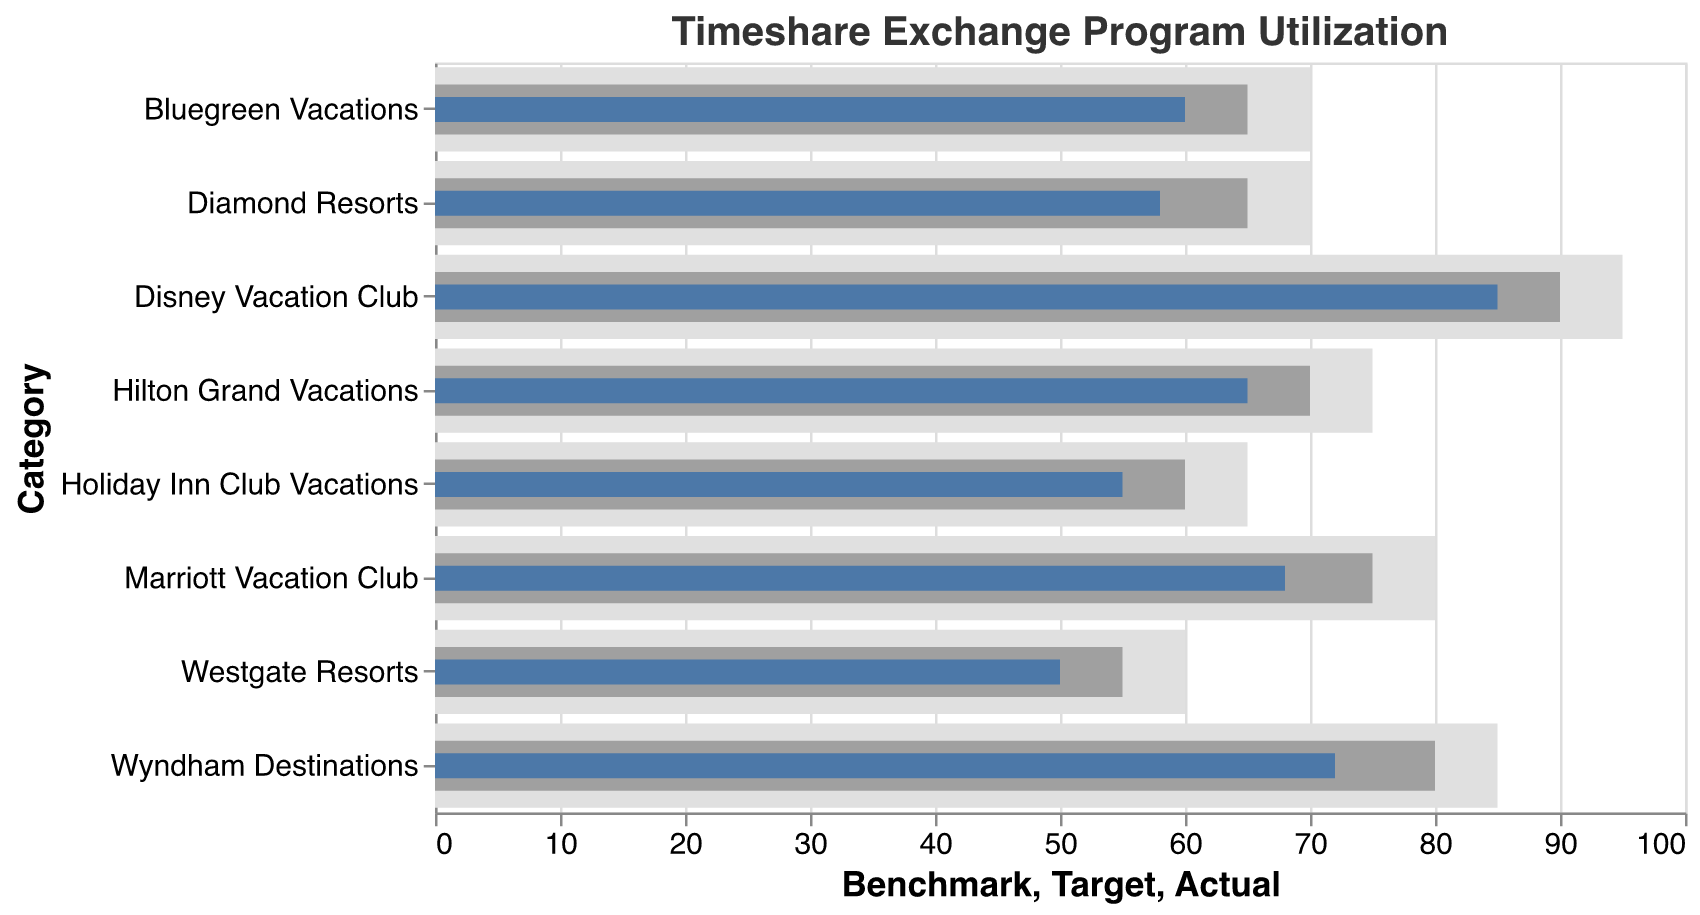What's the title of the chart? The title is typically the text at the top of the visual chart which summarizes its content. Here, it reads "Timeshare Exchange Program Utilization".
Answer: Timeshare Exchange Program Utilization How many categories of timeshare programs are depicted in the chart? Each horizontal bar corresponds to a distinct timeshare program category. Counting each bar, it reveals there are eight categories listed.
Answer: Eight Which timeshare program has the highest actual utilization percentage? To find the highest actual utilization percentage, inspect the blue bars' lengths, as they represent actual utilization. The longest blue bar is for "Disney Vacation Club" with an actual percentage of 85%.
Answer: Disney Vacation Club Which timeshare program falls the most below its utilization target? Calculate the difference between the target and actual for each category. The largest difference occurs for "Holiday Inn Club Vacations", where the target is 60%, and the actual is 55%, resulting in a difference of 5%.
Answer: Holiday Inn Club Vacations Compare the actual utilization of "Marriott Vacation Club" and "Hilton Grand Vacations". Which is higher? Compare the blue bars' lengths for both categories. "Marriott Vacation Club" has an actual utilization of 68%, while "Hilton Grand Vacations" has 65%. Thus, "Marriott Vacation Club" is higher.
Answer: Marriott Vacation Club Which program has its actual usage closest to the benchmark? Examine the difference between the actual utilization and the benchmark for each category. The smallest difference is for "Marriott Vacation Club," where the benchmark is 80% and the actual usage is 68%, a difference of 12%.
Answer: Marriott Vacation Club What's the combined target utilization percentage for "Wyndham Destinations" and "Westgate Resorts"? Sum the target percentages for both categories. Wyndham Destinations' target is 80%, and Westgate Resorts' target is 55%, thus the combined target is 80% + 55% = 135%.
Answer: 135% How does the target utilization for "Bluegreen Vacations" compare to the actual utilization for "Diamond Resorts"? "Bluegreen Vacations" has a target utilization of 65%, while "Diamond Resorts" has an actual utilization of 58%. Therefore, "Bluegreen Vacations" has a higher target than the actual utilization of "Diamond Resorts".
Answer: Bluegreen Vacations Which timeshare program's actual utilization is closest to its target? Calculate the absolute difference between target and actual for each category. "Hilton Grand Vacations" has a target of 70% and an actual of 65%, having a difference of only 5%, which is the smallest.
Answer: Hilton Grand Vacations 